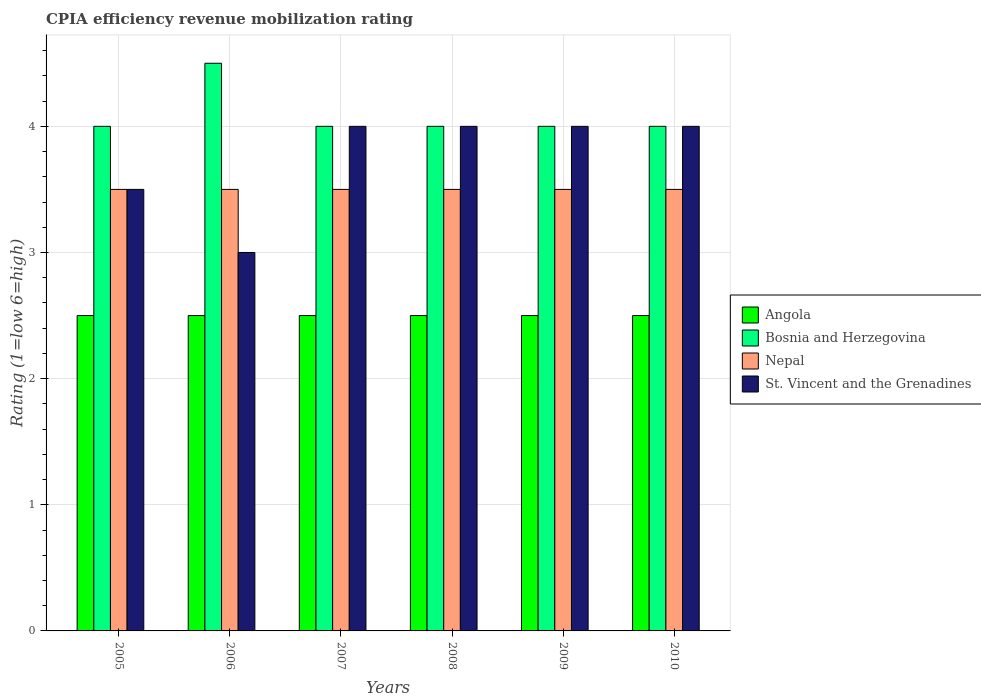How many different coloured bars are there?
Provide a succinct answer. 4. How many groups of bars are there?
Provide a succinct answer. 6. What is the label of the 3rd group of bars from the left?
Your answer should be compact. 2007. In how many cases, is the number of bars for a given year not equal to the number of legend labels?
Give a very brief answer. 0. In which year was the CPIA rating in St. Vincent and the Grenadines maximum?
Provide a short and direct response. 2007. In the year 2008, what is the difference between the CPIA rating in Nepal and CPIA rating in Angola?
Your response must be concise. 1. In how many years, is the CPIA rating in Bosnia and Herzegovina greater than 2?
Provide a succinct answer. 6. Is the difference between the CPIA rating in Nepal in 2006 and 2010 greater than the difference between the CPIA rating in Angola in 2006 and 2010?
Keep it short and to the point. No. What is the difference between the highest and the second highest CPIA rating in Nepal?
Make the answer very short. 0. What is the difference between the highest and the lowest CPIA rating in Nepal?
Give a very brief answer. 0. In how many years, is the CPIA rating in Bosnia and Herzegovina greater than the average CPIA rating in Bosnia and Herzegovina taken over all years?
Keep it short and to the point. 1. Is the sum of the CPIA rating in St. Vincent and the Grenadines in 2005 and 2010 greater than the maximum CPIA rating in Nepal across all years?
Make the answer very short. Yes. What does the 4th bar from the left in 2006 represents?
Offer a very short reply. St. Vincent and the Grenadines. What does the 4th bar from the right in 2009 represents?
Ensure brevity in your answer.  Angola. Is it the case that in every year, the sum of the CPIA rating in St. Vincent and the Grenadines and CPIA rating in Angola is greater than the CPIA rating in Bosnia and Herzegovina?
Your answer should be compact. Yes. Where does the legend appear in the graph?
Offer a very short reply. Center right. How are the legend labels stacked?
Give a very brief answer. Vertical. What is the title of the graph?
Ensure brevity in your answer.  CPIA efficiency revenue mobilization rating. What is the label or title of the X-axis?
Offer a terse response. Years. What is the Rating (1=low 6=high) in Bosnia and Herzegovina in 2005?
Make the answer very short. 4. What is the Rating (1=low 6=high) of Nepal in 2006?
Your answer should be very brief. 3.5. What is the Rating (1=low 6=high) of St. Vincent and the Grenadines in 2006?
Ensure brevity in your answer.  3. What is the Rating (1=low 6=high) in Angola in 2007?
Give a very brief answer. 2.5. What is the Rating (1=low 6=high) in St. Vincent and the Grenadines in 2007?
Make the answer very short. 4. What is the Rating (1=low 6=high) in Bosnia and Herzegovina in 2008?
Provide a short and direct response. 4. What is the Rating (1=low 6=high) of Bosnia and Herzegovina in 2009?
Provide a succinct answer. 4. What is the Rating (1=low 6=high) of Nepal in 2009?
Give a very brief answer. 3.5. What is the Rating (1=low 6=high) in Angola in 2010?
Your answer should be compact. 2.5. What is the Rating (1=low 6=high) in Bosnia and Herzegovina in 2010?
Offer a terse response. 4. What is the Rating (1=low 6=high) in Nepal in 2010?
Offer a terse response. 3.5. What is the Rating (1=low 6=high) in St. Vincent and the Grenadines in 2010?
Make the answer very short. 4. Across all years, what is the minimum Rating (1=low 6=high) in Angola?
Provide a succinct answer. 2.5. Across all years, what is the minimum Rating (1=low 6=high) in Bosnia and Herzegovina?
Give a very brief answer. 4. Across all years, what is the minimum Rating (1=low 6=high) of Nepal?
Make the answer very short. 3.5. Across all years, what is the minimum Rating (1=low 6=high) in St. Vincent and the Grenadines?
Offer a terse response. 3. What is the total Rating (1=low 6=high) of Bosnia and Herzegovina in the graph?
Make the answer very short. 24.5. What is the total Rating (1=low 6=high) of Nepal in the graph?
Provide a succinct answer. 21. What is the difference between the Rating (1=low 6=high) of Angola in 2005 and that in 2006?
Give a very brief answer. 0. What is the difference between the Rating (1=low 6=high) in Bosnia and Herzegovina in 2005 and that in 2006?
Give a very brief answer. -0.5. What is the difference between the Rating (1=low 6=high) in Bosnia and Herzegovina in 2005 and that in 2007?
Provide a short and direct response. 0. What is the difference between the Rating (1=low 6=high) in St. Vincent and the Grenadines in 2005 and that in 2007?
Provide a short and direct response. -0.5. What is the difference between the Rating (1=low 6=high) in Bosnia and Herzegovina in 2005 and that in 2008?
Make the answer very short. 0. What is the difference between the Rating (1=low 6=high) of St. Vincent and the Grenadines in 2005 and that in 2008?
Offer a terse response. -0.5. What is the difference between the Rating (1=low 6=high) of Bosnia and Herzegovina in 2005 and that in 2009?
Provide a short and direct response. 0. What is the difference between the Rating (1=low 6=high) of Angola in 2005 and that in 2010?
Your answer should be compact. 0. What is the difference between the Rating (1=low 6=high) in Nepal in 2005 and that in 2010?
Give a very brief answer. 0. What is the difference between the Rating (1=low 6=high) in St. Vincent and the Grenadines in 2005 and that in 2010?
Your answer should be compact. -0.5. What is the difference between the Rating (1=low 6=high) in Nepal in 2006 and that in 2007?
Your answer should be very brief. 0. What is the difference between the Rating (1=low 6=high) in St. Vincent and the Grenadines in 2006 and that in 2007?
Offer a very short reply. -1. What is the difference between the Rating (1=low 6=high) of Bosnia and Herzegovina in 2006 and that in 2008?
Your answer should be very brief. 0.5. What is the difference between the Rating (1=low 6=high) in St. Vincent and the Grenadines in 2006 and that in 2008?
Your answer should be very brief. -1. What is the difference between the Rating (1=low 6=high) in Angola in 2006 and that in 2010?
Keep it short and to the point. 0. What is the difference between the Rating (1=low 6=high) of St. Vincent and the Grenadines in 2006 and that in 2010?
Your response must be concise. -1. What is the difference between the Rating (1=low 6=high) of Angola in 2007 and that in 2008?
Offer a very short reply. 0. What is the difference between the Rating (1=low 6=high) in Bosnia and Herzegovina in 2007 and that in 2008?
Give a very brief answer. 0. What is the difference between the Rating (1=low 6=high) of Nepal in 2007 and that in 2008?
Provide a short and direct response. 0. What is the difference between the Rating (1=low 6=high) in St. Vincent and the Grenadines in 2007 and that in 2008?
Your answer should be very brief. 0. What is the difference between the Rating (1=low 6=high) of Bosnia and Herzegovina in 2007 and that in 2009?
Keep it short and to the point. 0. What is the difference between the Rating (1=low 6=high) of Nepal in 2007 and that in 2009?
Your answer should be compact. 0. What is the difference between the Rating (1=low 6=high) in Bosnia and Herzegovina in 2007 and that in 2010?
Offer a very short reply. 0. What is the difference between the Rating (1=low 6=high) of Nepal in 2007 and that in 2010?
Your response must be concise. 0. What is the difference between the Rating (1=low 6=high) in Angola in 2008 and that in 2009?
Your response must be concise. 0. What is the difference between the Rating (1=low 6=high) of St. Vincent and the Grenadines in 2008 and that in 2009?
Keep it short and to the point. 0. What is the difference between the Rating (1=low 6=high) of Bosnia and Herzegovina in 2008 and that in 2010?
Make the answer very short. 0. What is the difference between the Rating (1=low 6=high) in Nepal in 2008 and that in 2010?
Your answer should be compact. 0. What is the difference between the Rating (1=low 6=high) in Angola in 2009 and that in 2010?
Make the answer very short. 0. What is the difference between the Rating (1=low 6=high) of Nepal in 2009 and that in 2010?
Keep it short and to the point. 0. What is the difference between the Rating (1=low 6=high) of St. Vincent and the Grenadines in 2009 and that in 2010?
Offer a terse response. 0. What is the difference between the Rating (1=low 6=high) of Angola in 2005 and the Rating (1=low 6=high) of Nepal in 2006?
Give a very brief answer. -1. What is the difference between the Rating (1=low 6=high) of Angola in 2005 and the Rating (1=low 6=high) of St. Vincent and the Grenadines in 2006?
Your response must be concise. -0.5. What is the difference between the Rating (1=low 6=high) in Angola in 2005 and the Rating (1=low 6=high) in Bosnia and Herzegovina in 2007?
Offer a terse response. -1.5. What is the difference between the Rating (1=low 6=high) in Nepal in 2005 and the Rating (1=low 6=high) in St. Vincent and the Grenadines in 2007?
Offer a very short reply. -0.5. What is the difference between the Rating (1=low 6=high) of Angola in 2005 and the Rating (1=low 6=high) of Bosnia and Herzegovina in 2008?
Your answer should be compact. -1.5. What is the difference between the Rating (1=low 6=high) in Bosnia and Herzegovina in 2005 and the Rating (1=low 6=high) in Nepal in 2008?
Your answer should be compact. 0.5. What is the difference between the Rating (1=low 6=high) in Bosnia and Herzegovina in 2005 and the Rating (1=low 6=high) in St. Vincent and the Grenadines in 2008?
Provide a succinct answer. 0. What is the difference between the Rating (1=low 6=high) in Nepal in 2005 and the Rating (1=low 6=high) in St. Vincent and the Grenadines in 2009?
Make the answer very short. -0.5. What is the difference between the Rating (1=low 6=high) of Angola in 2005 and the Rating (1=low 6=high) of Bosnia and Herzegovina in 2010?
Give a very brief answer. -1.5. What is the difference between the Rating (1=low 6=high) in Bosnia and Herzegovina in 2006 and the Rating (1=low 6=high) in St. Vincent and the Grenadines in 2007?
Your answer should be very brief. 0.5. What is the difference between the Rating (1=low 6=high) of Nepal in 2006 and the Rating (1=low 6=high) of St. Vincent and the Grenadines in 2007?
Your response must be concise. -0.5. What is the difference between the Rating (1=low 6=high) of Angola in 2006 and the Rating (1=low 6=high) of Bosnia and Herzegovina in 2008?
Offer a very short reply. -1.5. What is the difference between the Rating (1=low 6=high) in Angola in 2006 and the Rating (1=low 6=high) in Nepal in 2008?
Make the answer very short. -1. What is the difference between the Rating (1=low 6=high) in Bosnia and Herzegovina in 2006 and the Rating (1=low 6=high) in Nepal in 2008?
Give a very brief answer. 1. What is the difference between the Rating (1=low 6=high) in Bosnia and Herzegovina in 2006 and the Rating (1=low 6=high) in St. Vincent and the Grenadines in 2008?
Provide a succinct answer. 0.5. What is the difference between the Rating (1=low 6=high) in Angola in 2006 and the Rating (1=low 6=high) in Nepal in 2009?
Offer a terse response. -1. What is the difference between the Rating (1=low 6=high) of Angola in 2006 and the Rating (1=low 6=high) of St. Vincent and the Grenadines in 2009?
Keep it short and to the point. -1.5. What is the difference between the Rating (1=low 6=high) of Bosnia and Herzegovina in 2006 and the Rating (1=low 6=high) of Nepal in 2009?
Give a very brief answer. 1. What is the difference between the Rating (1=low 6=high) of Angola in 2006 and the Rating (1=low 6=high) of Bosnia and Herzegovina in 2010?
Provide a succinct answer. -1.5. What is the difference between the Rating (1=low 6=high) in Angola in 2006 and the Rating (1=low 6=high) in St. Vincent and the Grenadines in 2010?
Your response must be concise. -1.5. What is the difference between the Rating (1=low 6=high) of Bosnia and Herzegovina in 2006 and the Rating (1=low 6=high) of Nepal in 2010?
Your answer should be very brief. 1. What is the difference between the Rating (1=low 6=high) of Bosnia and Herzegovina in 2006 and the Rating (1=low 6=high) of St. Vincent and the Grenadines in 2010?
Provide a succinct answer. 0.5. What is the difference between the Rating (1=low 6=high) in Nepal in 2006 and the Rating (1=low 6=high) in St. Vincent and the Grenadines in 2010?
Give a very brief answer. -0.5. What is the difference between the Rating (1=low 6=high) in Angola in 2007 and the Rating (1=low 6=high) in Nepal in 2008?
Ensure brevity in your answer.  -1. What is the difference between the Rating (1=low 6=high) of Bosnia and Herzegovina in 2007 and the Rating (1=low 6=high) of Nepal in 2008?
Ensure brevity in your answer.  0.5. What is the difference between the Rating (1=low 6=high) of Bosnia and Herzegovina in 2007 and the Rating (1=low 6=high) of St. Vincent and the Grenadines in 2008?
Provide a succinct answer. 0. What is the difference between the Rating (1=low 6=high) in Angola in 2007 and the Rating (1=low 6=high) in Nepal in 2009?
Provide a short and direct response. -1. What is the difference between the Rating (1=low 6=high) in Angola in 2007 and the Rating (1=low 6=high) in St. Vincent and the Grenadines in 2009?
Your answer should be compact. -1.5. What is the difference between the Rating (1=low 6=high) of Bosnia and Herzegovina in 2007 and the Rating (1=low 6=high) of Nepal in 2009?
Ensure brevity in your answer.  0.5. What is the difference between the Rating (1=low 6=high) in Nepal in 2007 and the Rating (1=low 6=high) in St. Vincent and the Grenadines in 2009?
Ensure brevity in your answer.  -0.5. What is the difference between the Rating (1=low 6=high) of Angola in 2007 and the Rating (1=low 6=high) of Bosnia and Herzegovina in 2010?
Ensure brevity in your answer.  -1.5. What is the difference between the Rating (1=low 6=high) of Angola in 2008 and the Rating (1=low 6=high) of Bosnia and Herzegovina in 2009?
Provide a succinct answer. -1.5. What is the difference between the Rating (1=low 6=high) of Angola in 2008 and the Rating (1=low 6=high) of Nepal in 2009?
Your response must be concise. -1. What is the difference between the Rating (1=low 6=high) in Bosnia and Herzegovina in 2008 and the Rating (1=low 6=high) in Nepal in 2009?
Your answer should be very brief. 0.5. What is the difference between the Rating (1=low 6=high) in Bosnia and Herzegovina in 2008 and the Rating (1=low 6=high) in St. Vincent and the Grenadines in 2009?
Make the answer very short. 0. What is the difference between the Rating (1=low 6=high) in Nepal in 2008 and the Rating (1=low 6=high) in St. Vincent and the Grenadines in 2009?
Your answer should be compact. -0.5. What is the difference between the Rating (1=low 6=high) of Bosnia and Herzegovina in 2008 and the Rating (1=low 6=high) of Nepal in 2010?
Keep it short and to the point. 0.5. What is the difference between the Rating (1=low 6=high) in Angola in 2009 and the Rating (1=low 6=high) in Bosnia and Herzegovina in 2010?
Make the answer very short. -1.5. What is the difference between the Rating (1=low 6=high) in Angola in 2009 and the Rating (1=low 6=high) in St. Vincent and the Grenadines in 2010?
Your answer should be compact. -1.5. What is the difference between the Rating (1=low 6=high) in Bosnia and Herzegovina in 2009 and the Rating (1=low 6=high) in Nepal in 2010?
Ensure brevity in your answer.  0.5. What is the difference between the Rating (1=low 6=high) in Bosnia and Herzegovina in 2009 and the Rating (1=low 6=high) in St. Vincent and the Grenadines in 2010?
Ensure brevity in your answer.  0. What is the average Rating (1=low 6=high) in Bosnia and Herzegovina per year?
Offer a very short reply. 4.08. What is the average Rating (1=low 6=high) of St. Vincent and the Grenadines per year?
Provide a short and direct response. 3.75. In the year 2005, what is the difference between the Rating (1=low 6=high) of Bosnia and Herzegovina and Rating (1=low 6=high) of Nepal?
Your response must be concise. 0.5. In the year 2005, what is the difference between the Rating (1=low 6=high) of Bosnia and Herzegovina and Rating (1=low 6=high) of St. Vincent and the Grenadines?
Provide a succinct answer. 0.5. In the year 2006, what is the difference between the Rating (1=low 6=high) of Angola and Rating (1=low 6=high) of Nepal?
Offer a very short reply. -1. In the year 2006, what is the difference between the Rating (1=low 6=high) of Angola and Rating (1=low 6=high) of St. Vincent and the Grenadines?
Provide a short and direct response. -0.5. In the year 2006, what is the difference between the Rating (1=low 6=high) in Bosnia and Herzegovina and Rating (1=low 6=high) in Nepal?
Make the answer very short. 1. In the year 2006, what is the difference between the Rating (1=low 6=high) in Bosnia and Herzegovina and Rating (1=low 6=high) in St. Vincent and the Grenadines?
Make the answer very short. 1.5. In the year 2006, what is the difference between the Rating (1=low 6=high) in Nepal and Rating (1=low 6=high) in St. Vincent and the Grenadines?
Your answer should be compact. 0.5. In the year 2007, what is the difference between the Rating (1=low 6=high) in Angola and Rating (1=low 6=high) in Bosnia and Herzegovina?
Offer a very short reply. -1.5. In the year 2007, what is the difference between the Rating (1=low 6=high) in Bosnia and Herzegovina and Rating (1=low 6=high) in Nepal?
Keep it short and to the point. 0.5. In the year 2008, what is the difference between the Rating (1=low 6=high) of Angola and Rating (1=low 6=high) of Nepal?
Provide a short and direct response. -1. In the year 2008, what is the difference between the Rating (1=low 6=high) in Nepal and Rating (1=low 6=high) in St. Vincent and the Grenadines?
Make the answer very short. -0.5. In the year 2009, what is the difference between the Rating (1=low 6=high) in Angola and Rating (1=low 6=high) in Nepal?
Offer a terse response. -1. In the year 2009, what is the difference between the Rating (1=low 6=high) of Angola and Rating (1=low 6=high) of St. Vincent and the Grenadines?
Offer a very short reply. -1.5. In the year 2009, what is the difference between the Rating (1=low 6=high) of Bosnia and Herzegovina and Rating (1=low 6=high) of St. Vincent and the Grenadines?
Your response must be concise. 0. In the year 2009, what is the difference between the Rating (1=low 6=high) of Nepal and Rating (1=low 6=high) of St. Vincent and the Grenadines?
Your response must be concise. -0.5. In the year 2010, what is the difference between the Rating (1=low 6=high) of Angola and Rating (1=low 6=high) of Nepal?
Offer a terse response. -1. In the year 2010, what is the difference between the Rating (1=low 6=high) in Bosnia and Herzegovina and Rating (1=low 6=high) in Nepal?
Offer a terse response. 0.5. In the year 2010, what is the difference between the Rating (1=low 6=high) in Bosnia and Herzegovina and Rating (1=low 6=high) in St. Vincent and the Grenadines?
Provide a short and direct response. 0. What is the ratio of the Rating (1=low 6=high) of Angola in 2005 to that in 2006?
Provide a short and direct response. 1. What is the ratio of the Rating (1=low 6=high) of St. Vincent and the Grenadines in 2005 to that in 2006?
Make the answer very short. 1.17. What is the ratio of the Rating (1=low 6=high) in Angola in 2005 to that in 2007?
Ensure brevity in your answer.  1. What is the ratio of the Rating (1=low 6=high) of Nepal in 2005 to that in 2007?
Offer a very short reply. 1. What is the ratio of the Rating (1=low 6=high) of Angola in 2005 to that in 2008?
Your answer should be compact. 1. What is the ratio of the Rating (1=low 6=high) in Bosnia and Herzegovina in 2005 to that in 2008?
Your response must be concise. 1. What is the ratio of the Rating (1=low 6=high) of Nepal in 2005 to that in 2008?
Keep it short and to the point. 1. What is the ratio of the Rating (1=low 6=high) in St. Vincent and the Grenadines in 2005 to that in 2008?
Offer a very short reply. 0.88. What is the ratio of the Rating (1=low 6=high) of Bosnia and Herzegovina in 2005 to that in 2009?
Ensure brevity in your answer.  1. What is the ratio of the Rating (1=low 6=high) in St. Vincent and the Grenadines in 2005 to that in 2009?
Your answer should be compact. 0.88. What is the ratio of the Rating (1=low 6=high) in Angola in 2005 to that in 2010?
Make the answer very short. 1. What is the ratio of the Rating (1=low 6=high) in Bosnia and Herzegovina in 2005 to that in 2010?
Your response must be concise. 1. What is the ratio of the Rating (1=low 6=high) in St. Vincent and the Grenadines in 2005 to that in 2010?
Provide a short and direct response. 0.88. What is the ratio of the Rating (1=low 6=high) of St. Vincent and the Grenadines in 2006 to that in 2007?
Make the answer very short. 0.75. What is the ratio of the Rating (1=low 6=high) of Bosnia and Herzegovina in 2006 to that in 2008?
Provide a short and direct response. 1.12. What is the ratio of the Rating (1=low 6=high) in Nepal in 2006 to that in 2008?
Your answer should be compact. 1. What is the ratio of the Rating (1=low 6=high) of St. Vincent and the Grenadines in 2006 to that in 2008?
Offer a terse response. 0.75. What is the ratio of the Rating (1=low 6=high) in Bosnia and Herzegovina in 2006 to that in 2009?
Offer a terse response. 1.12. What is the ratio of the Rating (1=low 6=high) in Angola in 2006 to that in 2010?
Offer a terse response. 1. What is the ratio of the Rating (1=low 6=high) in Angola in 2007 to that in 2008?
Ensure brevity in your answer.  1. What is the ratio of the Rating (1=low 6=high) of Nepal in 2007 to that in 2008?
Provide a short and direct response. 1. What is the ratio of the Rating (1=low 6=high) of Bosnia and Herzegovina in 2007 to that in 2009?
Offer a very short reply. 1. What is the ratio of the Rating (1=low 6=high) in Angola in 2007 to that in 2010?
Give a very brief answer. 1. What is the ratio of the Rating (1=low 6=high) of Bosnia and Herzegovina in 2007 to that in 2010?
Provide a short and direct response. 1. What is the ratio of the Rating (1=low 6=high) in Nepal in 2007 to that in 2010?
Make the answer very short. 1. What is the ratio of the Rating (1=low 6=high) of Bosnia and Herzegovina in 2008 to that in 2009?
Give a very brief answer. 1. What is the ratio of the Rating (1=low 6=high) in Nepal in 2008 to that in 2009?
Ensure brevity in your answer.  1. What is the ratio of the Rating (1=low 6=high) of St. Vincent and the Grenadines in 2008 to that in 2009?
Your answer should be compact. 1. What is the ratio of the Rating (1=low 6=high) in Angola in 2008 to that in 2010?
Provide a short and direct response. 1. What is the ratio of the Rating (1=low 6=high) in Nepal in 2008 to that in 2010?
Your answer should be very brief. 1. What is the ratio of the Rating (1=low 6=high) of St. Vincent and the Grenadines in 2008 to that in 2010?
Provide a short and direct response. 1. What is the ratio of the Rating (1=low 6=high) of Bosnia and Herzegovina in 2009 to that in 2010?
Your answer should be very brief. 1. What is the ratio of the Rating (1=low 6=high) of St. Vincent and the Grenadines in 2009 to that in 2010?
Your answer should be very brief. 1. What is the difference between the highest and the second highest Rating (1=low 6=high) in Angola?
Make the answer very short. 0. What is the difference between the highest and the second highest Rating (1=low 6=high) of Bosnia and Herzegovina?
Offer a very short reply. 0.5. What is the difference between the highest and the second highest Rating (1=low 6=high) of Nepal?
Your response must be concise. 0. What is the difference between the highest and the second highest Rating (1=low 6=high) in St. Vincent and the Grenadines?
Provide a succinct answer. 0. What is the difference between the highest and the lowest Rating (1=low 6=high) of Nepal?
Make the answer very short. 0. 